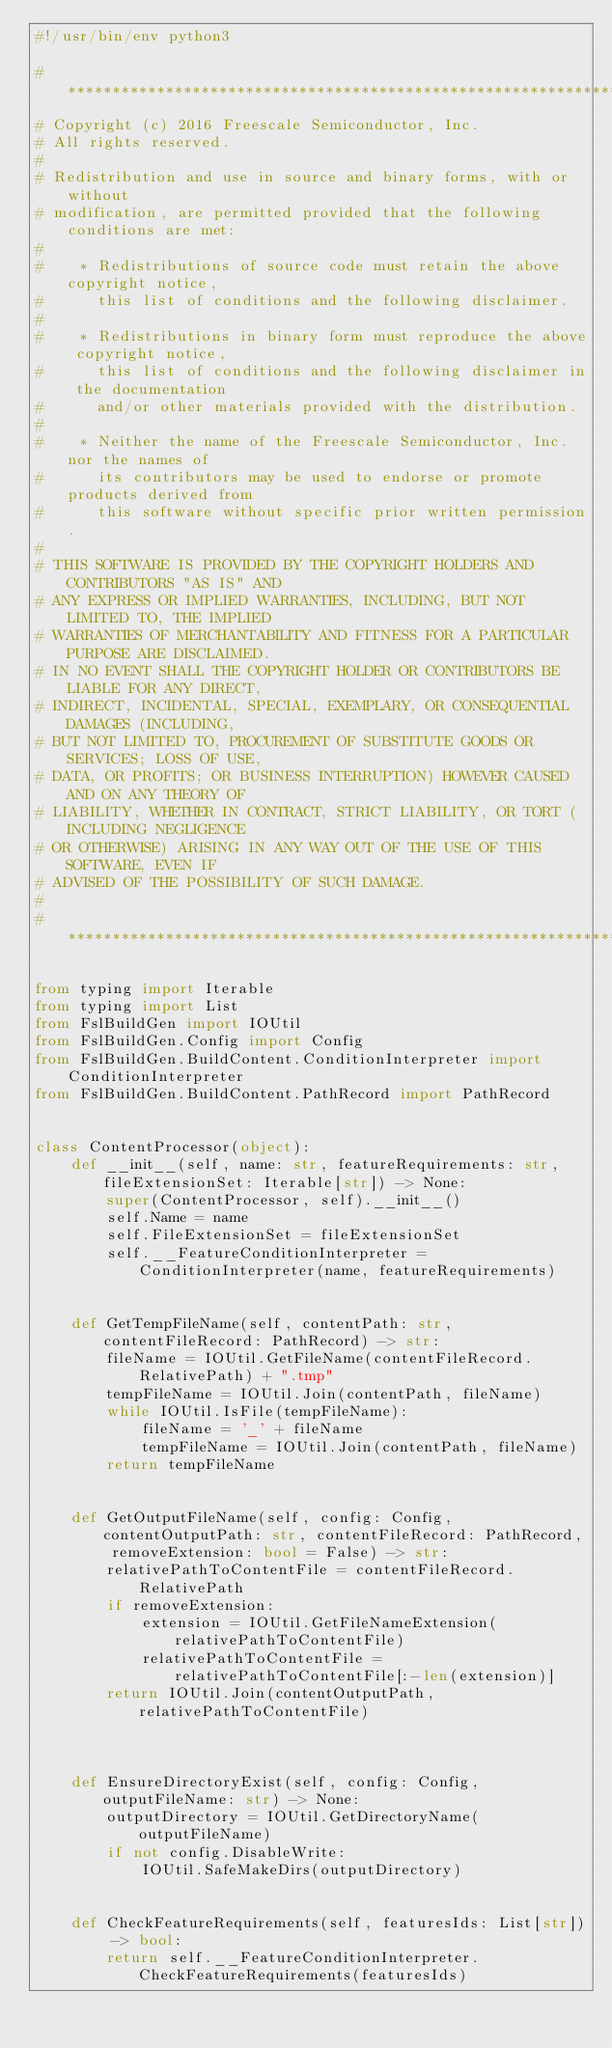Convert code to text. <code><loc_0><loc_0><loc_500><loc_500><_Python_>#!/usr/bin/env python3

#****************************************************************************************************************************************************
# Copyright (c) 2016 Freescale Semiconductor, Inc.
# All rights reserved.
#
# Redistribution and use in source and binary forms, with or without
# modification, are permitted provided that the following conditions are met:
#
#    * Redistributions of source code must retain the above copyright notice,
#      this list of conditions and the following disclaimer.
#
#    * Redistributions in binary form must reproduce the above copyright notice,
#      this list of conditions and the following disclaimer in the documentation
#      and/or other materials provided with the distribution.
#
#    * Neither the name of the Freescale Semiconductor, Inc. nor the names of
#      its contributors may be used to endorse or promote products derived from
#      this software without specific prior written permission.
#
# THIS SOFTWARE IS PROVIDED BY THE COPYRIGHT HOLDERS AND CONTRIBUTORS "AS IS" AND
# ANY EXPRESS OR IMPLIED WARRANTIES, INCLUDING, BUT NOT LIMITED TO, THE IMPLIED
# WARRANTIES OF MERCHANTABILITY AND FITNESS FOR A PARTICULAR PURPOSE ARE DISCLAIMED.
# IN NO EVENT SHALL THE COPYRIGHT HOLDER OR CONTRIBUTORS BE LIABLE FOR ANY DIRECT,
# INDIRECT, INCIDENTAL, SPECIAL, EXEMPLARY, OR CONSEQUENTIAL DAMAGES (INCLUDING,
# BUT NOT LIMITED TO, PROCUREMENT OF SUBSTITUTE GOODS OR SERVICES; LOSS OF USE,
# DATA, OR PROFITS; OR BUSINESS INTERRUPTION) HOWEVER CAUSED AND ON ANY THEORY OF
# LIABILITY, WHETHER IN CONTRACT, STRICT LIABILITY, OR TORT (INCLUDING NEGLIGENCE
# OR OTHERWISE) ARISING IN ANY WAY OUT OF THE USE OF THIS SOFTWARE, EVEN IF
# ADVISED OF THE POSSIBILITY OF SUCH DAMAGE.
#
#****************************************************************************************************************************************************

from typing import Iterable
from typing import List
from FslBuildGen import IOUtil
from FslBuildGen.Config import Config
from FslBuildGen.BuildContent.ConditionInterpreter import ConditionInterpreter
from FslBuildGen.BuildContent.PathRecord import PathRecord


class ContentProcessor(object):
    def __init__(self, name: str, featureRequirements: str, fileExtensionSet: Iterable[str]) -> None:
        super(ContentProcessor, self).__init__()
        self.Name = name
        self.FileExtensionSet = fileExtensionSet
        self.__FeatureConditionInterpreter = ConditionInterpreter(name, featureRequirements)


    def GetTempFileName(self, contentPath: str, contentFileRecord: PathRecord) -> str:
        fileName = IOUtil.GetFileName(contentFileRecord.RelativePath) + ".tmp"
        tempFileName = IOUtil.Join(contentPath, fileName)
        while IOUtil.IsFile(tempFileName):
            fileName = '_' + fileName
            tempFileName = IOUtil.Join(contentPath, fileName)
        return tempFileName


    def GetOutputFileName(self, config: Config, contentOutputPath: str, contentFileRecord: PathRecord, removeExtension: bool = False) -> str:
        relativePathToContentFile = contentFileRecord.RelativePath
        if removeExtension:
            extension = IOUtil.GetFileNameExtension(relativePathToContentFile)
            relativePathToContentFile = relativePathToContentFile[:-len(extension)]
        return IOUtil.Join(contentOutputPath, relativePathToContentFile)



    def EnsureDirectoryExist(self, config: Config, outputFileName: str) -> None:
        outputDirectory = IOUtil.GetDirectoryName(outputFileName)
        if not config.DisableWrite:
            IOUtil.SafeMakeDirs(outputDirectory)


    def CheckFeatureRequirements(self, featuresIds: List[str]) -> bool:
        return self.__FeatureConditionInterpreter.CheckFeatureRequirements(featuresIds)
</code> 